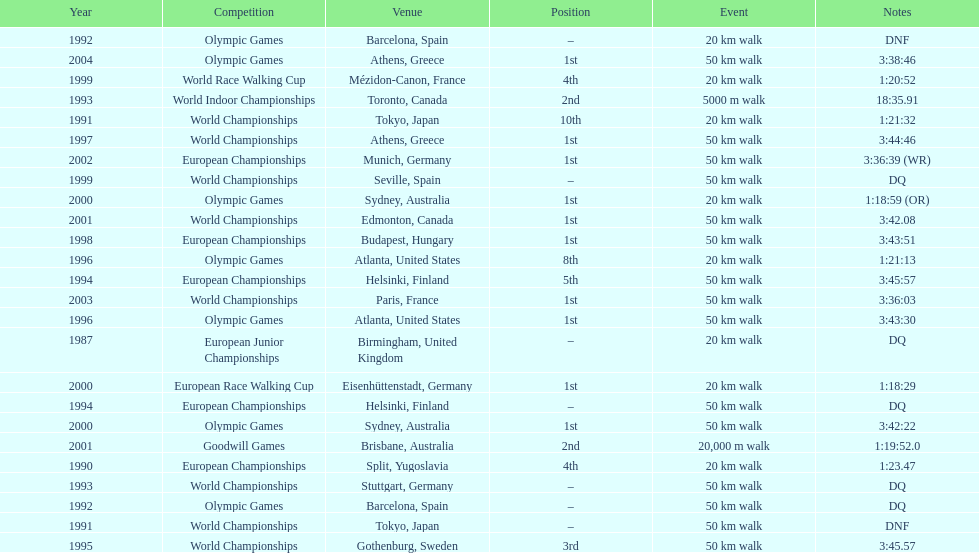Which venue is listed the most? Athens, Greece. I'm looking to parse the entire table for insights. Could you assist me with that? {'header': ['Year', 'Competition', 'Venue', 'Position', 'Event', 'Notes'], 'rows': [['1992', 'Olympic Games', 'Barcelona, Spain', '–', '20\xa0km walk', 'DNF'], ['2004', 'Olympic Games', 'Athens, Greece', '1st', '50\xa0km walk', '3:38:46'], ['1999', 'World Race Walking Cup', 'Mézidon-Canon, France', '4th', '20\xa0km walk', '1:20:52'], ['1993', 'World Indoor Championships', 'Toronto, Canada', '2nd', '5000 m walk', '18:35.91'], ['1991', 'World Championships', 'Tokyo, Japan', '10th', '20\xa0km walk', '1:21:32'], ['1997', 'World Championships', 'Athens, Greece', '1st', '50\xa0km walk', '3:44:46'], ['2002', 'European Championships', 'Munich, Germany', '1st', '50\xa0km walk', '3:36:39 (WR)'], ['1999', 'World Championships', 'Seville, Spain', '–', '50\xa0km walk', 'DQ'], ['2000', 'Olympic Games', 'Sydney, Australia', '1st', '20\xa0km walk', '1:18:59 (OR)'], ['2001', 'World Championships', 'Edmonton, Canada', '1st', '50\xa0km walk', '3:42.08'], ['1998', 'European Championships', 'Budapest, Hungary', '1st', '50\xa0km walk', '3:43:51'], ['1996', 'Olympic Games', 'Atlanta, United States', '8th', '20\xa0km walk', '1:21:13'], ['1994', 'European Championships', 'Helsinki, Finland', '5th', '50\xa0km walk', '3:45:57'], ['2003', 'World Championships', 'Paris, France', '1st', '50\xa0km walk', '3:36:03'], ['1996', 'Olympic Games', 'Atlanta, United States', '1st', '50\xa0km walk', '3:43:30'], ['1987', 'European Junior Championships', 'Birmingham, United Kingdom', '–', '20\xa0km walk', 'DQ'], ['2000', 'European Race Walking Cup', 'Eisenhüttenstadt, Germany', '1st', '20\xa0km walk', '1:18:29'], ['1994', 'European Championships', 'Helsinki, Finland', '–', '50\xa0km walk', 'DQ'], ['2000', 'Olympic Games', 'Sydney, Australia', '1st', '50\xa0km walk', '3:42:22'], ['2001', 'Goodwill Games', 'Brisbane, Australia', '2nd', '20,000 m walk', '1:19:52.0'], ['1990', 'European Championships', 'Split, Yugoslavia', '4th', '20\xa0km walk', '1:23.47'], ['1993', 'World Championships', 'Stuttgart, Germany', '–', '50\xa0km walk', 'DQ'], ['1992', 'Olympic Games', 'Barcelona, Spain', '–', '50\xa0km walk', 'DQ'], ['1991', 'World Championships', 'Tokyo, Japan', '–', '50\xa0km walk', 'DNF'], ['1995', 'World Championships', 'Gothenburg, Sweden', '3rd', '50\xa0km walk', '3:45.57']]} 